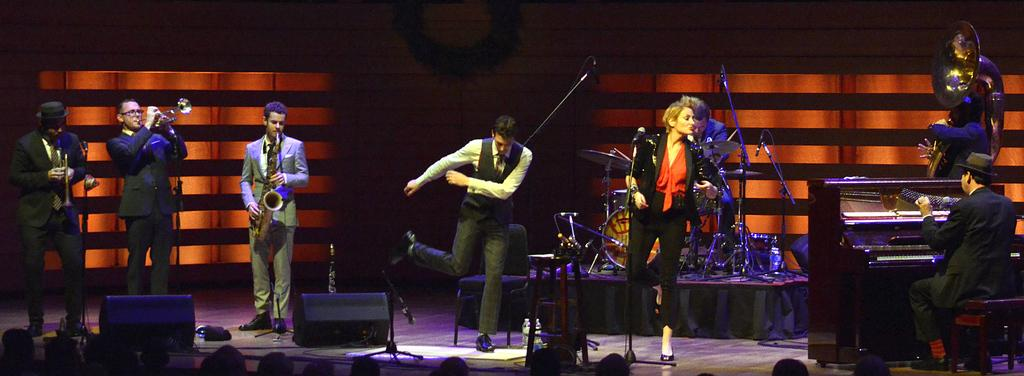What are the people in the image doing? Some of the people in the image are playing musical instruments. What objects are present at the bottom of the image? There are speakers at the bottom of the image. What devices are used for amplifying the sound of the musical instruments? Microphones are placed on stands in the image. Can you see any goldfish swimming in the image? There are no goldfish present in the image. What type of rod is being used by the people in the image? There is no rod visible in the image; the people are playing musical instruments. 